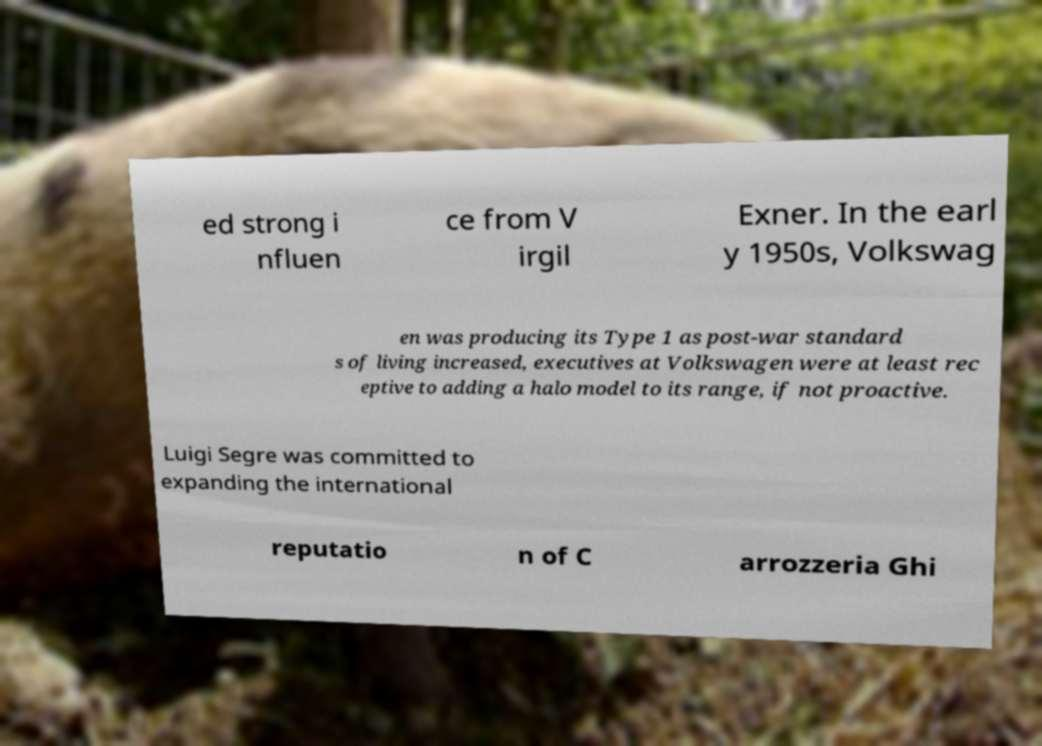Please identify and transcribe the text found in this image. ed strong i nfluen ce from V irgil Exner. In the earl y 1950s, Volkswag en was producing its Type 1 as post-war standard s of living increased, executives at Volkswagen were at least rec eptive to adding a halo model to its range, if not proactive. Luigi Segre was committed to expanding the international reputatio n of C arrozzeria Ghi 